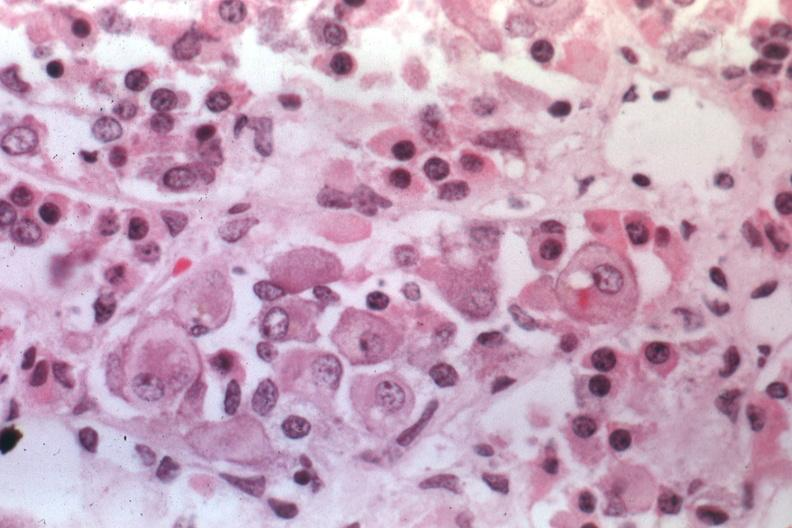s metastatic carcinoma prostate present?
Answer the question using a single word or phrase. No 